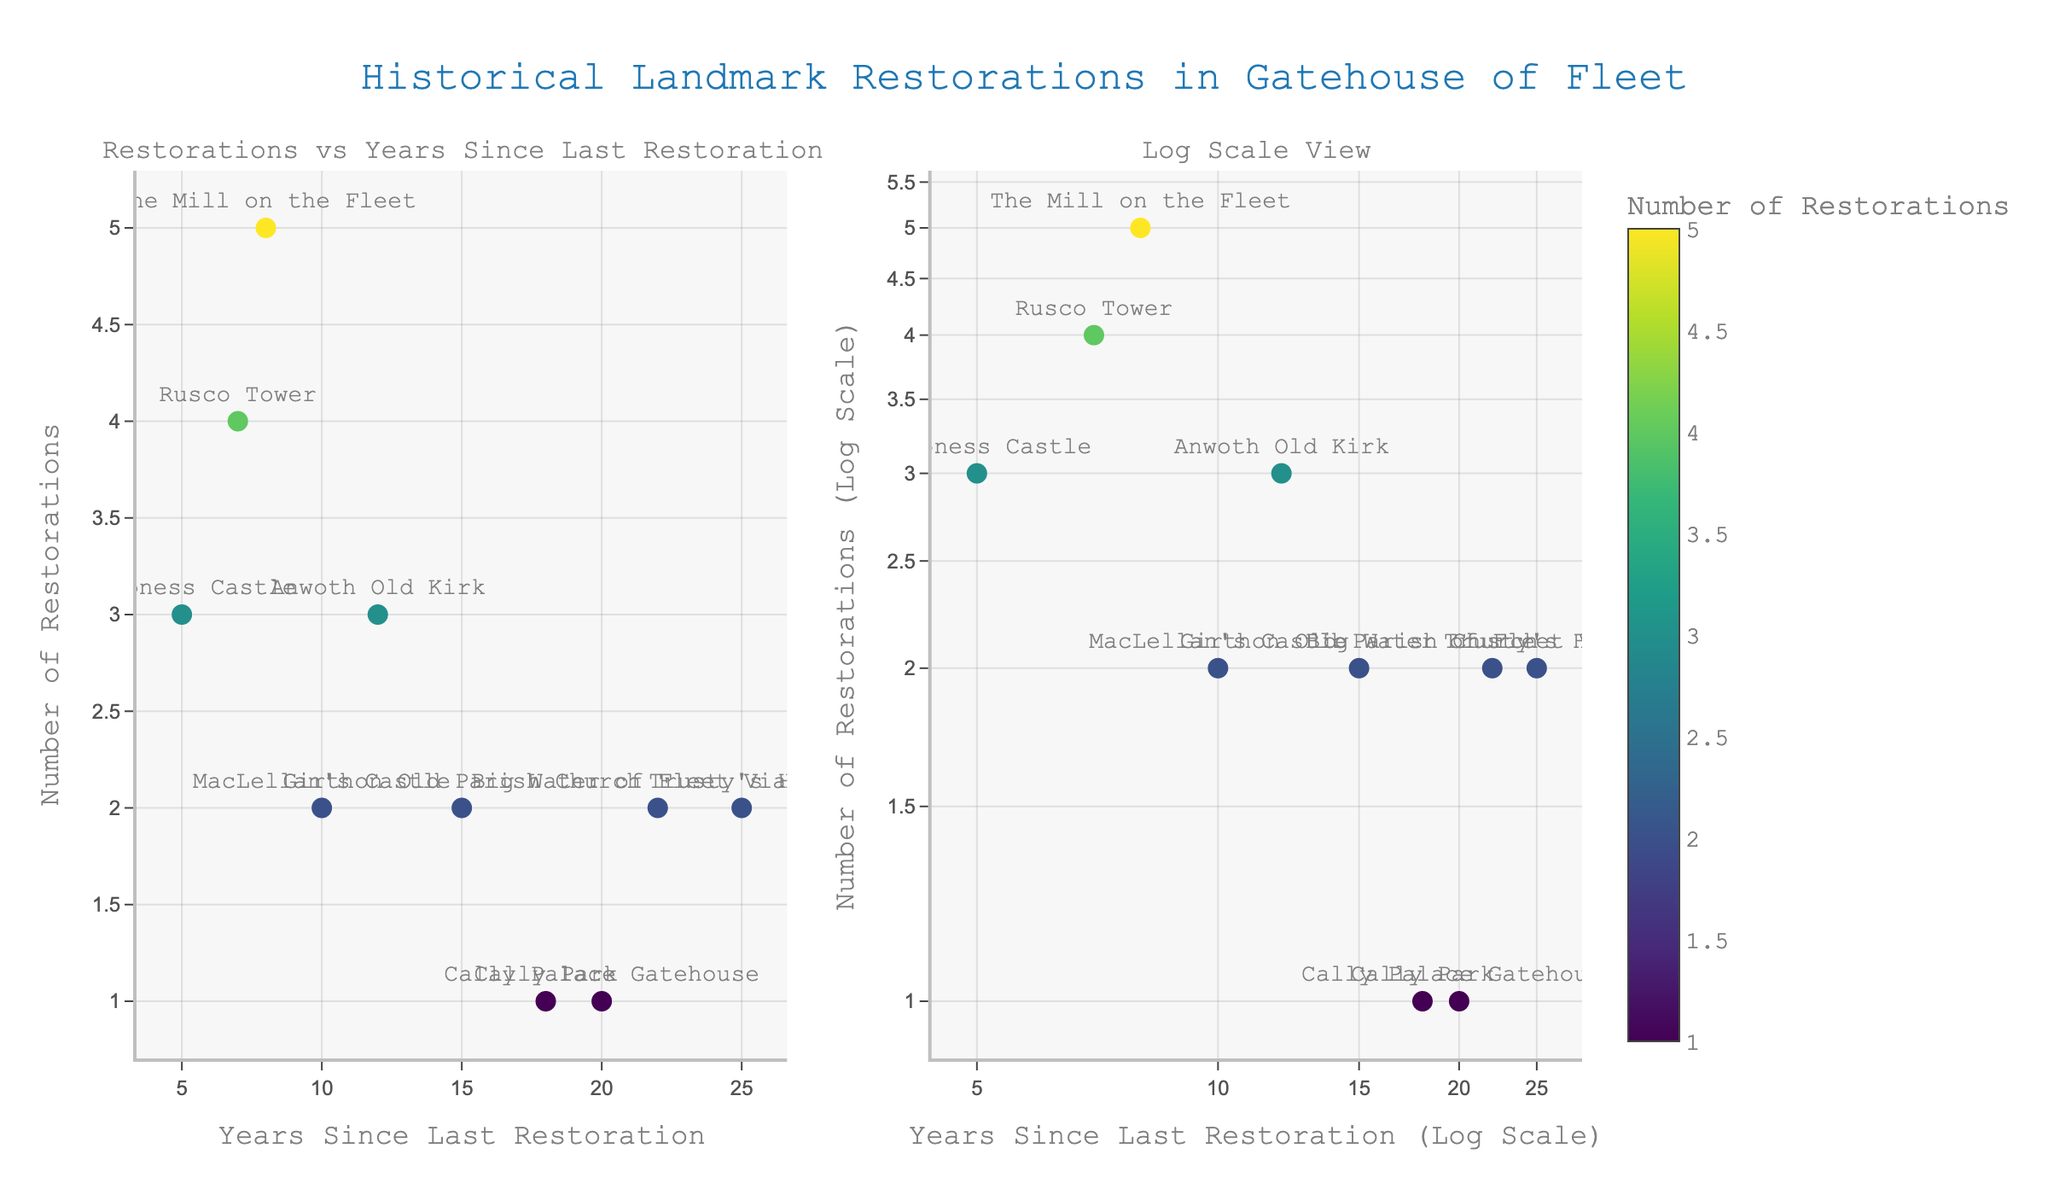What's the title of the figure? The title of the figure is usually found at the top center of the plot, enunciating the main topic it covers.
Answer: Historical Landmark Restorations in Gatehouse of Fleet How many landmarks have been restored? To determine the number of landmarks, count the individual markers corresponding to each landmark on the plot.
Answer: 10 Which landmark has the highest number of restorations? By identifying the marker with the highest y-value in the scatter plot, you can see which landmark has the most restorations.
Answer: The Mill on the Fleet Which landmark has not been restored for the longest time? Find the landmark with the highest x-value in the scatter plot to see which one has not been restored for the longest period.
Answer: Trusty's Hill Comparing Big Water of Fleet Viaduct and Cally Park, which landmark has had more restorations? Compare the y-values of both landmarks to determine which has had more restorations.
Answer: Big Water of Fleet Viaduct What's the logarithmic years since the last restoration for Anwoth Old Kirk in the log scale subplot? Observe Anwoth Old Kirk's x-value in the log scale subplot for the years since the last restoration.
Answer: Approximately 10^1.08 How many landmarks have been restored more than twice? Identify the markers above the y-value of 2 in both subplots to count the number of landmarks restored more than twice.
Answer: 5 What's the difference in the number of restorations between Rusco Tower and Cally Park? Subtract the number of restorations of Cally Park from Rusco Tower.
Answer: 3 If you were to average the number of years since the last restoration for all landmarks, what would it be? Sum all the years since the last restoration for each landmark and divide by the total number of landmarks (10).
Answer: 14.2 Is there a trend noticeable in the number of restorations over time in either of the subplots? Assess the general direction of the data points across the x-axis and y-axis in both subplots to recognize any trend.
Answer: No clear trend 